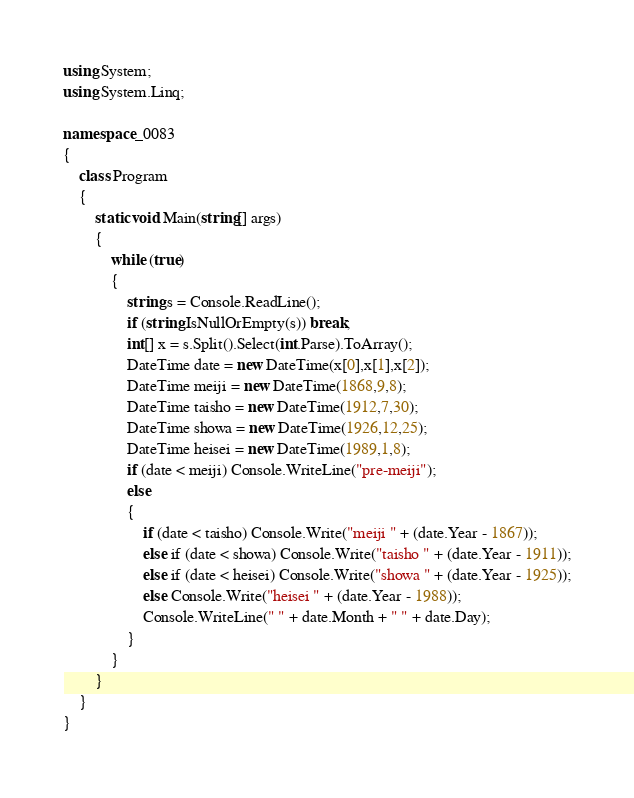<code> <loc_0><loc_0><loc_500><loc_500><_C#_>using System;
using System.Linq;

namespace _0083
{
    class Program
    {
        static void Main(string[] args)
        {
            while (true)
            {
                string s = Console.ReadLine();
                if (string.IsNullOrEmpty(s)) break;
                int[] x = s.Split().Select(int.Parse).ToArray();
                DateTime date = new DateTime(x[0],x[1],x[2]);
                DateTime meiji = new DateTime(1868,9,8);
                DateTime taisho = new DateTime(1912,7,30);
                DateTime showa = new DateTime(1926,12,25);
                DateTime heisei = new DateTime(1989,1,8);
                if (date < meiji) Console.WriteLine("pre-meiji");
                else
                {
                    if (date < taisho) Console.Write("meiji " + (date.Year - 1867));
                    else if (date < showa) Console.Write("taisho " + (date.Year - 1911));
                    else if (date < heisei) Console.Write("showa " + (date.Year - 1925));
                    else Console.Write("heisei " + (date.Year - 1988));
                    Console.WriteLine(" " + date.Month + " " + date.Day);
                }
            }
        }
    }
}
</code> 